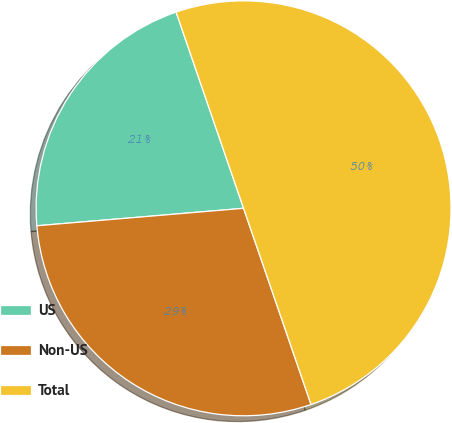<chart> <loc_0><loc_0><loc_500><loc_500><pie_chart><fcel>US<fcel>Non-US<fcel>Total<nl><fcel>21.07%<fcel>28.93%<fcel>50.0%<nl></chart> 